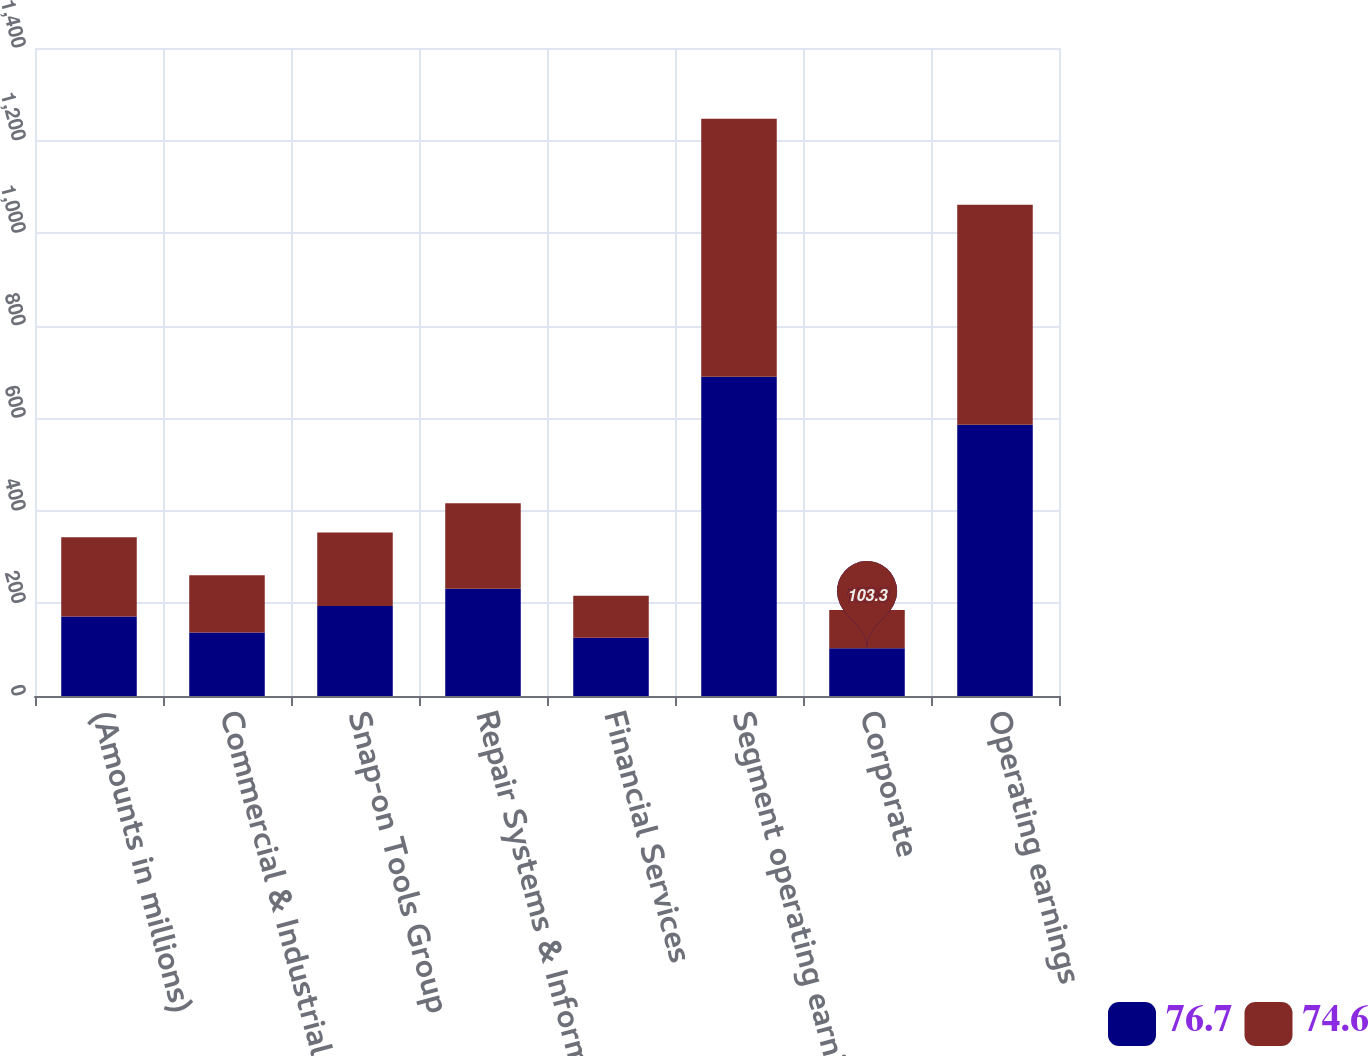<chart> <loc_0><loc_0><loc_500><loc_500><stacked_bar_chart><ecel><fcel>(Amounts in millions)<fcel>Commercial & Industrial Group<fcel>Snap-on Tools Group<fcel>Repair Systems & Information<fcel>Financial Services<fcel>Segment operating earnings<fcel>Corporate<fcel>Operating earnings<nl><fcel>76.7<fcel>171.6<fcel>137.3<fcel>194.6<fcel>231.9<fcel>125.7<fcel>689.5<fcel>103.3<fcel>586.2<nl><fcel>74.6<fcel>171.6<fcel>123.4<fcel>158.5<fcel>184.7<fcel>90.9<fcel>557.5<fcel>82.4<fcel>475.1<nl></chart> 